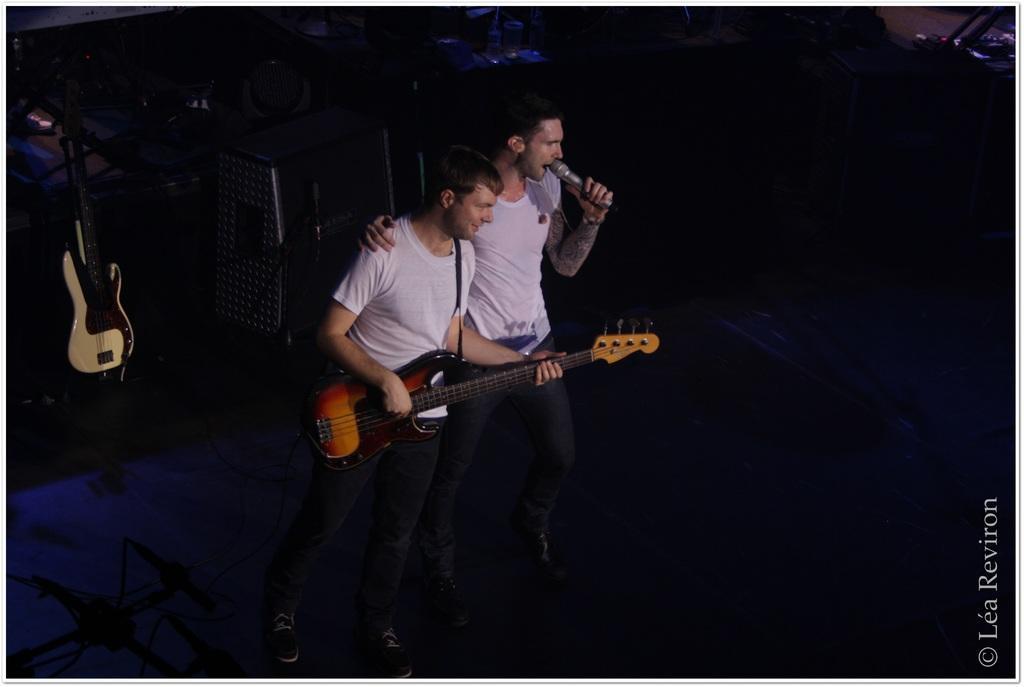Describe this image in one or two sentences. In this image there are two mans who are in standing position. The right person is signing on a mic and on the left person is playing a guitar. On the left there is a guitar. 